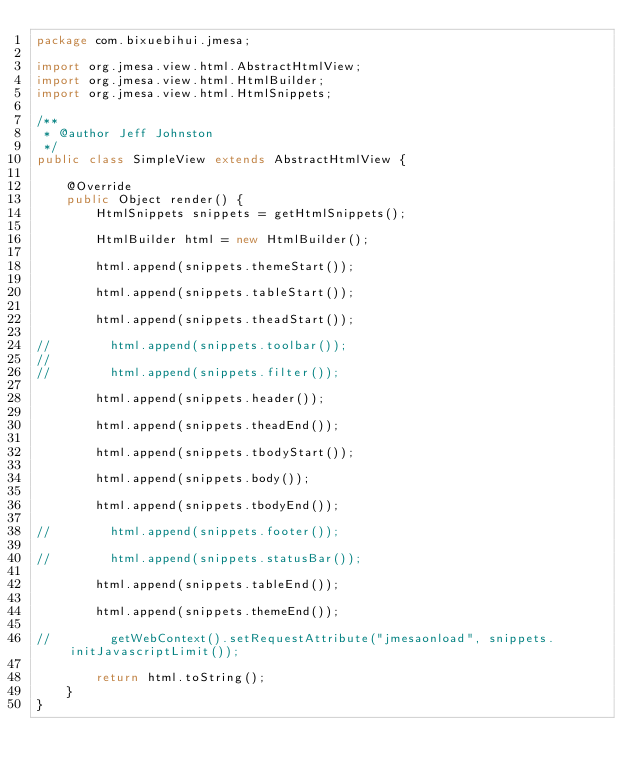Convert code to text. <code><loc_0><loc_0><loc_500><loc_500><_Java_>package com.bixuebihui.jmesa;

import org.jmesa.view.html.AbstractHtmlView;
import org.jmesa.view.html.HtmlBuilder;
import org.jmesa.view.html.HtmlSnippets;

/**
 * @author Jeff Johnston
 */
public class SimpleView extends AbstractHtmlView {

    @Override
    public Object render() {
        HtmlSnippets snippets = getHtmlSnippets();

        HtmlBuilder html = new HtmlBuilder();

        html.append(snippets.themeStart());

        html.append(snippets.tableStart());

        html.append(snippets.theadStart());

//        html.append(snippets.toolbar());
//
//        html.append(snippets.filter());

        html.append(snippets.header());

        html.append(snippets.theadEnd());

        html.append(snippets.tbodyStart());

        html.append(snippets.body());

        html.append(snippets.tbodyEnd());

//        html.append(snippets.footer());

//        html.append(snippets.statusBar());

        html.append(snippets.tableEnd());

        html.append(snippets.themeEnd());

//        getWebContext().setRequestAttribute("jmesaonload", snippets.initJavascriptLimit());

        return html.toString();
    }
}
</code> 